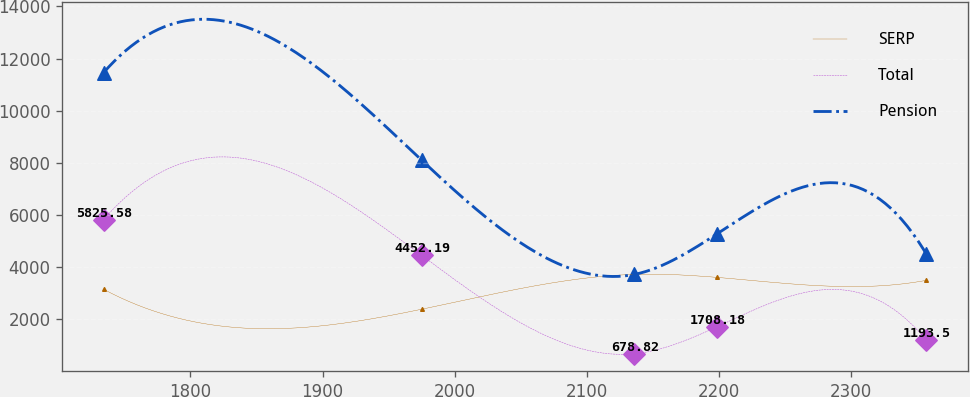Convert chart. <chart><loc_0><loc_0><loc_500><loc_500><line_chart><ecel><fcel>SERP<fcel>Total<fcel>Pension<nl><fcel>1734.23<fcel>3153.24<fcel>5825.58<fcel>11457.8<nl><fcel>1974.97<fcel>2386.5<fcel>4452.19<fcel>8103.54<nl><fcel>2135.94<fcel>3722.68<fcel>678.82<fcel>3722.26<nl><fcel>2198.2<fcel>3609.19<fcel>1708.18<fcel>5269.38<nl><fcel>2356.88<fcel>3495.7<fcel>1193.5<fcel>4495.82<nl></chart> 